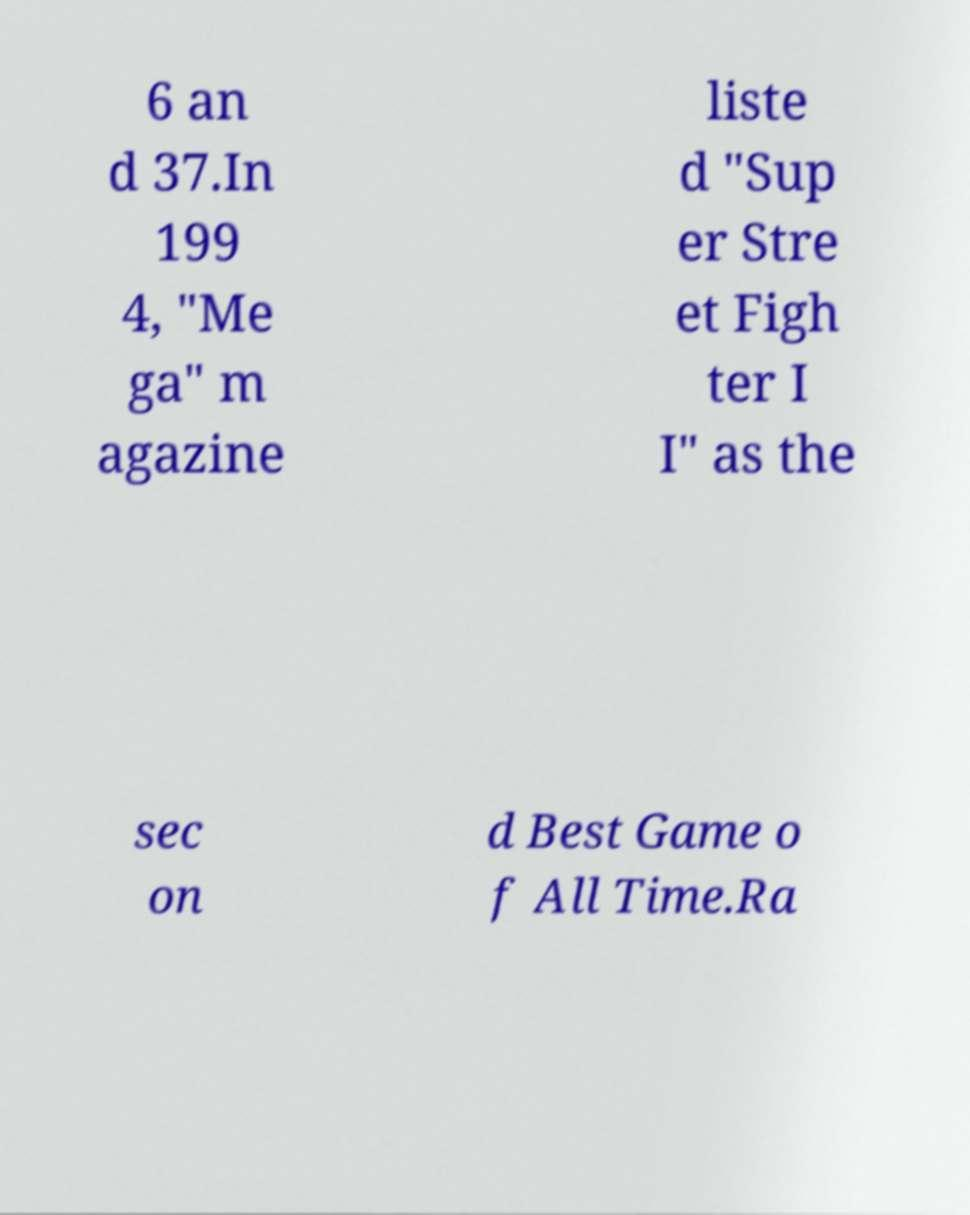What messages or text are displayed in this image? I need them in a readable, typed format. 6 an d 37.In 199 4, "Me ga" m agazine liste d "Sup er Stre et Figh ter I I" as the sec on d Best Game o f All Time.Ra 